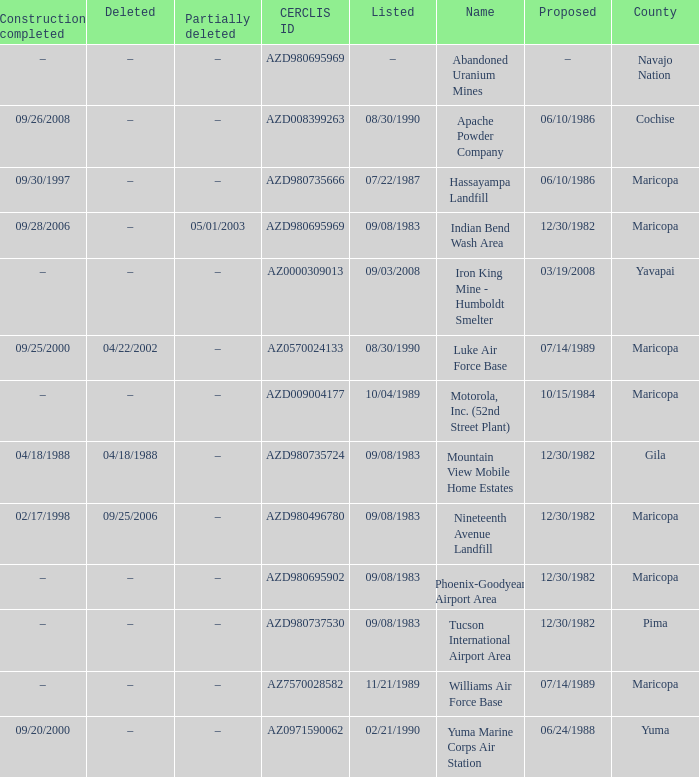Could you help me parse every detail presented in this table? {'header': ['Construction completed', 'Deleted', 'Partially deleted', 'CERCLIS ID', 'Listed', 'Name', 'Proposed', 'County'], 'rows': [['–', '–', '–', 'AZD980695969', '–', 'Abandoned Uranium Mines', '–', 'Navajo Nation'], ['09/26/2008', '–', '–', 'AZD008399263', '08/30/1990', 'Apache Powder Company', '06/10/1986', 'Cochise'], ['09/30/1997', '–', '–', 'AZD980735666', '07/22/1987', 'Hassayampa Landfill', '06/10/1986', 'Maricopa'], ['09/28/2006', '–', '05/01/2003', 'AZD980695969', '09/08/1983', 'Indian Bend Wash Area', '12/30/1982', 'Maricopa'], ['–', '–', '–', 'AZ0000309013', '09/03/2008', 'Iron King Mine - Humboldt Smelter', '03/19/2008', 'Yavapai'], ['09/25/2000', '04/22/2002', '–', 'AZ0570024133', '08/30/1990', 'Luke Air Force Base', '07/14/1989', 'Maricopa'], ['–', '–', '–', 'AZD009004177', '10/04/1989', 'Motorola, Inc. (52nd Street Plant)', '10/15/1984', 'Maricopa'], ['04/18/1988', '04/18/1988', '–', 'AZD980735724', '09/08/1983', 'Mountain View Mobile Home Estates', '12/30/1982', 'Gila'], ['02/17/1998', '09/25/2006', '–', 'AZD980496780', '09/08/1983', 'Nineteenth Avenue Landfill', '12/30/1982', 'Maricopa'], ['–', '–', '–', 'AZD980695902', '09/08/1983', 'Phoenix-Goodyear Airport Area', '12/30/1982', 'Maricopa'], ['–', '–', '–', 'AZD980737530', '09/08/1983', 'Tucson International Airport Area', '12/30/1982', 'Pima'], ['–', '–', '–', 'AZ7570028582', '11/21/1989', 'Williams Air Force Base', '07/14/1989', 'Maricopa'], ['09/20/2000', '–', '–', 'AZ0971590062', '02/21/1990', 'Yuma Marine Corps Air Station', '06/24/1988', 'Yuma']]} When was the site listed when the county is cochise? 08/30/1990. 